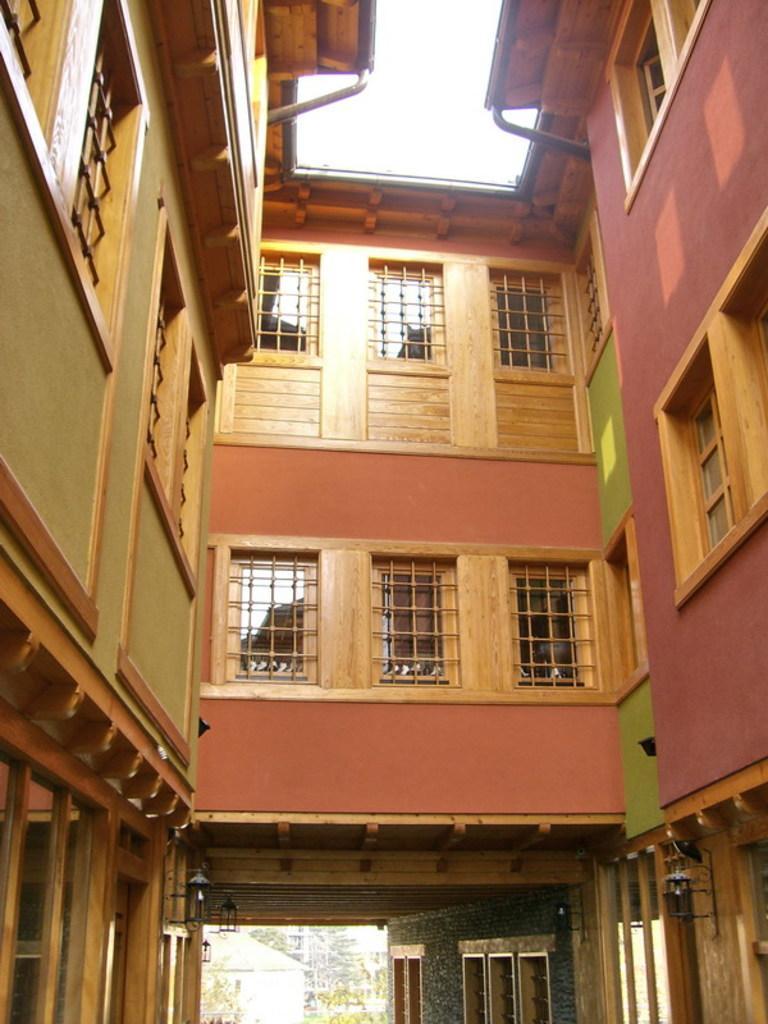Describe this image in one or two sentences. In this image I can see the buildings with windows. In the background I can see the shed, trees and the sky. 